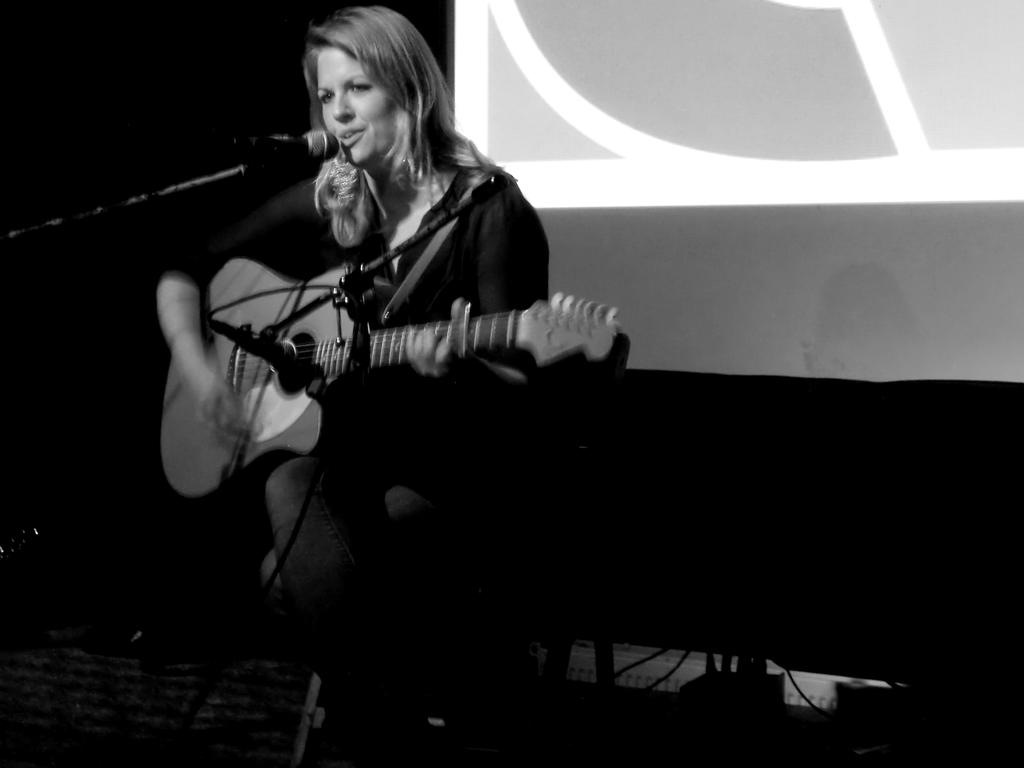What is the woman in the image doing? The woman is playing a guitar and singing a song. What object is present in front of the woman? There is a microphone present in front of the woman. What is located behind the woman in the image? There is a projector screen behind the woman. How many lizards can be seen crawling on the guitar in the image? There are no lizards present in the image; the woman is playing a guitar without any lizards on it. 